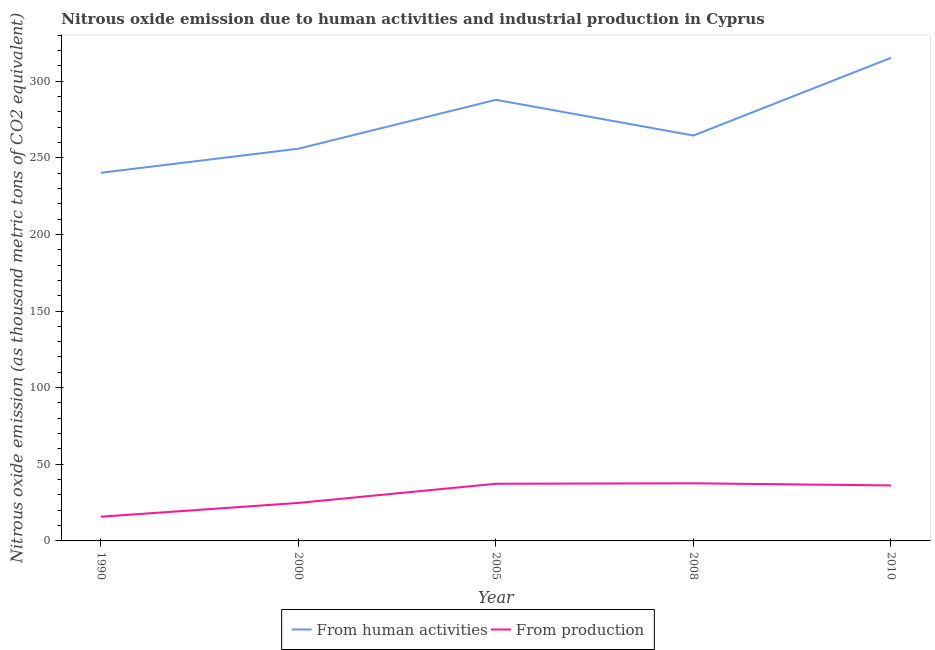Does the line corresponding to amount of emissions generated from industries intersect with the line corresponding to amount of emissions from human activities?
Your response must be concise. No. Is the number of lines equal to the number of legend labels?
Your answer should be compact. Yes. What is the amount of emissions from human activities in 2008?
Make the answer very short. 264.5. Across all years, what is the maximum amount of emissions from human activities?
Offer a very short reply. 315.2. Across all years, what is the minimum amount of emissions from human activities?
Your response must be concise. 240.2. What is the total amount of emissions from human activities in the graph?
Ensure brevity in your answer.  1363.6. What is the difference between the amount of emissions from human activities in 1990 and that in 2005?
Offer a terse response. -47.6. What is the difference between the amount of emissions generated from industries in 2008 and the amount of emissions from human activities in 1990?
Your response must be concise. -202.6. What is the average amount of emissions from human activities per year?
Ensure brevity in your answer.  272.72. In the year 2000, what is the difference between the amount of emissions from human activities and amount of emissions generated from industries?
Provide a succinct answer. 231.1. What is the ratio of the amount of emissions from human activities in 1990 to that in 2000?
Your response must be concise. 0.94. Is the amount of emissions generated from industries in 2000 less than that in 2010?
Your answer should be compact. Yes. What is the difference between the highest and the second highest amount of emissions generated from industries?
Your answer should be compact. 0.3. What is the difference between the highest and the lowest amount of emissions generated from industries?
Your response must be concise. 21.8. In how many years, is the amount of emissions generated from industries greater than the average amount of emissions generated from industries taken over all years?
Ensure brevity in your answer.  3. Is the sum of the amount of emissions generated from industries in 2000 and 2005 greater than the maximum amount of emissions from human activities across all years?
Ensure brevity in your answer.  No. Is the amount of emissions generated from industries strictly less than the amount of emissions from human activities over the years?
Ensure brevity in your answer.  Yes. How many years are there in the graph?
Keep it short and to the point. 5. What is the difference between two consecutive major ticks on the Y-axis?
Provide a succinct answer. 50. Are the values on the major ticks of Y-axis written in scientific E-notation?
Your answer should be compact. No. Does the graph contain any zero values?
Offer a very short reply. No. Does the graph contain grids?
Make the answer very short. No. Where does the legend appear in the graph?
Provide a short and direct response. Bottom center. How are the legend labels stacked?
Your answer should be very brief. Horizontal. What is the title of the graph?
Offer a very short reply. Nitrous oxide emission due to human activities and industrial production in Cyprus. Does "Commercial service exports" appear as one of the legend labels in the graph?
Keep it short and to the point. No. What is the label or title of the X-axis?
Your answer should be very brief. Year. What is the label or title of the Y-axis?
Ensure brevity in your answer.  Nitrous oxide emission (as thousand metric tons of CO2 equivalent). What is the Nitrous oxide emission (as thousand metric tons of CO2 equivalent) in From human activities in 1990?
Make the answer very short. 240.2. What is the Nitrous oxide emission (as thousand metric tons of CO2 equivalent) in From human activities in 2000?
Provide a succinct answer. 255.9. What is the Nitrous oxide emission (as thousand metric tons of CO2 equivalent) of From production in 2000?
Offer a very short reply. 24.8. What is the Nitrous oxide emission (as thousand metric tons of CO2 equivalent) of From human activities in 2005?
Your answer should be compact. 287.8. What is the Nitrous oxide emission (as thousand metric tons of CO2 equivalent) of From production in 2005?
Your response must be concise. 37.3. What is the Nitrous oxide emission (as thousand metric tons of CO2 equivalent) in From human activities in 2008?
Keep it short and to the point. 264.5. What is the Nitrous oxide emission (as thousand metric tons of CO2 equivalent) of From production in 2008?
Offer a very short reply. 37.6. What is the Nitrous oxide emission (as thousand metric tons of CO2 equivalent) of From human activities in 2010?
Offer a very short reply. 315.2. What is the Nitrous oxide emission (as thousand metric tons of CO2 equivalent) in From production in 2010?
Make the answer very short. 36.2. Across all years, what is the maximum Nitrous oxide emission (as thousand metric tons of CO2 equivalent) of From human activities?
Make the answer very short. 315.2. Across all years, what is the maximum Nitrous oxide emission (as thousand metric tons of CO2 equivalent) in From production?
Ensure brevity in your answer.  37.6. Across all years, what is the minimum Nitrous oxide emission (as thousand metric tons of CO2 equivalent) of From human activities?
Your response must be concise. 240.2. What is the total Nitrous oxide emission (as thousand metric tons of CO2 equivalent) of From human activities in the graph?
Offer a very short reply. 1363.6. What is the total Nitrous oxide emission (as thousand metric tons of CO2 equivalent) in From production in the graph?
Your response must be concise. 151.7. What is the difference between the Nitrous oxide emission (as thousand metric tons of CO2 equivalent) in From human activities in 1990 and that in 2000?
Give a very brief answer. -15.7. What is the difference between the Nitrous oxide emission (as thousand metric tons of CO2 equivalent) in From human activities in 1990 and that in 2005?
Your answer should be compact. -47.6. What is the difference between the Nitrous oxide emission (as thousand metric tons of CO2 equivalent) in From production in 1990 and that in 2005?
Offer a terse response. -21.5. What is the difference between the Nitrous oxide emission (as thousand metric tons of CO2 equivalent) in From human activities in 1990 and that in 2008?
Your answer should be very brief. -24.3. What is the difference between the Nitrous oxide emission (as thousand metric tons of CO2 equivalent) of From production in 1990 and that in 2008?
Make the answer very short. -21.8. What is the difference between the Nitrous oxide emission (as thousand metric tons of CO2 equivalent) of From human activities in 1990 and that in 2010?
Offer a very short reply. -75. What is the difference between the Nitrous oxide emission (as thousand metric tons of CO2 equivalent) in From production in 1990 and that in 2010?
Make the answer very short. -20.4. What is the difference between the Nitrous oxide emission (as thousand metric tons of CO2 equivalent) in From human activities in 2000 and that in 2005?
Ensure brevity in your answer.  -31.9. What is the difference between the Nitrous oxide emission (as thousand metric tons of CO2 equivalent) of From production in 2000 and that in 2005?
Your response must be concise. -12.5. What is the difference between the Nitrous oxide emission (as thousand metric tons of CO2 equivalent) of From human activities in 2000 and that in 2008?
Keep it short and to the point. -8.6. What is the difference between the Nitrous oxide emission (as thousand metric tons of CO2 equivalent) in From production in 2000 and that in 2008?
Offer a terse response. -12.8. What is the difference between the Nitrous oxide emission (as thousand metric tons of CO2 equivalent) of From human activities in 2000 and that in 2010?
Offer a terse response. -59.3. What is the difference between the Nitrous oxide emission (as thousand metric tons of CO2 equivalent) of From human activities in 2005 and that in 2008?
Offer a terse response. 23.3. What is the difference between the Nitrous oxide emission (as thousand metric tons of CO2 equivalent) of From production in 2005 and that in 2008?
Ensure brevity in your answer.  -0.3. What is the difference between the Nitrous oxide emission (as thousand metric tons of CO2 equivalent) in From human activities in 2005 and that in 2010?
Your response must be concise. -27.4. What is the difference between the Nitrous oxide emission (as thousand metric tons of CO2 equivalent) of From human activities in 2008 and that in 2010?
Keep it short and to the point. -50.7. What is the difference between the Nitrous oxide emission (as thousand metric tons of CO2 equivalent) of From human activities in 1990 and the Nitrous oxide emission (as thousand metric tons of CO2 equivalent) of From production in 2000?
Your answer should be compact. 215.4. What is the difference between the Nitrous oxide emission (as thousand metric tons of CO2 equivalent) in From human activities in 1990 and the Nitrous oxide emission (as thousand metric tons of CO2 equivalent) in From production in 2005?
Provide a succinct answer. 202.9. What is the difference between the Nitrous oxide emission (as thousand metric tons of CO2 equivalent) of From human activities in 1990 and the Nitrous oxide emission (as thousand metric tons of CO2 equivalent) of From production in 2008?
Your answer should be compact. 202.6. What is the difference between the Nitrous oxide emission (as thousand metric tons of CO2 equivalent) in From human activities in 1990 and the Nitrous oxide emission (as thousand metric tons of CO2 equivalent) in From production in 2010?
Give a very brief answer. 204. What is the difference between the Nitrous oxide emission (as thousand metric tons of CO2 equivalent) of From human activities in 2000 and the Nitrous oxide emission (as thousand metric tons of CO2 equivalent) of From production in 2005?
Provide a succinct answer. 218.6. What is the difference between the Nitrous oxide emission (as thousand metric tons of CO2 equivalent) of From human activities in 2000 and the Nitrous oxide emission (as thousand metric tons of CO2 equivalent) of From production in 2008?
Your answer should be very brief. 218.3. What is the difference between the Nitrous oxide emission (as thousand metric tons of CO2 equivalent) of From human activities in 2000 and the Nitrous oxide emission (as thousand metric tons of CO2 equivalent) of From production in 2010?
Keep it short and to the point. 219.7. What is the difference between the Nitrous oxide emission (as thousand metric tons of CO2 equivalent) in From human activities in 2005 and the Nitrous oxide emission (as thousand metric tons of CO2 equivalent) in From production in 2008?
Keep it short and to the point. 250.2. What is the difference between the Nitrous oxide emission (as thousand metric tons of CO2 equivalent) in From human activities in 2005 and the Nitrous oxide emission (as thousand metric tons of CO2 equivalent) in From production in 2010?
Give a very brief answer. 251.6. What is the difference between the Nitrous oxide emission (as thousand metric tons of CO2 equivalent) of From human activities in 2008 and the Nitrous oxide emission (as thousand metric tons of CO2 equivalent) of From production in 2010?
Offer a terse response. 228.3. What is the average Nitrous oxide emission (as thousand metric tons of CO2 equivalent) in From human activities per year?
Keep it short and to the point. 272.72. What is the average Nitrous oxide emission (as thousand metric tons of CO2 equivalent) in From production per year?
Keep it short and to the point. 30.34. In the year 1990, what is the difference between the Nitrous oxide emission (as thousand metric tons of CO2 equivalent) in From human activities and Nitrous oxide emission (as thousand metric tons of CO2 equivalent) in From production?
Give a very brief answer. 224.4. In the year 2000, what is the difference between the Nitrous oxide emission (as thousand metric tons of CO2 equivalent) of From human activities and Nitrous oxide emission (as thousand metric tons of CO2 equivalent) of From production?
Offer a very short reply. 231.1. In the year 2005, what is the difference between the Nitrous oxide emission (as thousand metric tons of CO2 equivalent) in From human activities and Nitrous oxide emission (as thousand metric tons of CO2 equivalent) in From production?
Offer a very short reply. 250.5. In the year 2008, what is the difference between the Nitrous oxide emission (as thousand metric tons of CO2 equivalent) in From human activities and Nitrous oxide emission (as thousand metric tons of CO2 equivalent) in From production?
Your answer should be very brief. 226.9. In the year 2010, what is the difference between the Nitrous oxide emission (as thousand metric tons of CO2 equivalent) of From human activities and Nitrous oxide emission (as thousand metric tons of CO2 equivalent) of From production?
Your answer should be compact. 279. What is the ratio of the Nitrous oxide emission (as thousand metric tons of CO2 equivalent) of From human activities in 1990 to that in 2000?
Your answer should be very brief. 0.94. What is the ratio of the Nitrous oxide emission (as thousand metric tons of CO2 equivalent) in From production in 1990 to that in 2000?
Offer a terse response. 0.64. What is the ratio of the Nitrous oxide emission (as thousand metric tons of CO2 equivalent) of From human activities in 1990 to that in 2005?
Offer a terse response. 0.83. What is the ratio of the Nitrous oxide emission (as thousand metric tons of CO2 equivalent) of From production in 1990 to that in 2005?
Offer a terse response. 0.42. What is the ratio of the Nitrous oxide emission (as thousand metric tons of CO2 equivalent) of From human activities in 1990 to that in 2008?
Ensure brevity in your answer.  0.91. What is the ratio of the Nitrous oxide emission (as thousand metric tons of CO2 equivalent) in From production in 1990 to that in 2008?
Give a very brief answer. 0.42. What is the ratio of the Nitrous oxide emission (as thousand metric tons of CO2 equivalent) of From human activities in 1990 to that in 2010?
Offer a very short reply. 0.76. What is the ratio of the Nitrous oxide emission (as thousand metric tons of CO2 equivalent) of From production in 1990 to that in 2010?
Provide a short and direct response. 0.44. What is the ratio of the Nitrous oxide emission (as thousand metric tons of CO2 equivalent) in From human activities in 2000 to that in 2005?
Give a very brief answer. 0.89. What is the ratio of the Nitrous oxide emission (as thousand metric tons of CO2 equivalent) in From production in 2000 to that in 2005?
Your answer should be very brief. 0.66. What is the ratio of the Nitrous oxide emission (as thousand metric tons of CO2 equivalent) in From human activities in 2000 to that in 2008?
Provide a succinct answer. 0.97. What is the ratio of the Nitrous oxide emission (as thousand metric tons of CO2 equivalent) in From production in 2000 to that in 2008?
Offer a very short reply. 0.66. What is the ratio of the Nitrous oxide emission (as thousand metric tons of CO2 equivalent) in From human activities in 2000 to that in 2010?
Make the answer very short. 0.81. What is the ratio of the Nitrous oxide emission (as thousand metric tons of CO2 equivalent) in From production in 2000 to that in 2010?
Give a very brief answer. 0.69. What is the ratio of the Nitrous oxide emission (as thousand metric tons of CO2 equivalent) in From human activities in 2005 to that in 2008?
Give a very brief answer. 1.09. What is the ratio of the Nitrous oxide emission (as thousand metric tons of CO2 equivalent) in From production in 2005 to that in 2008?
Ensure brevity in your answer.  0.99. What is the ratio of the Nitrous oxide emission (as thousand metric tons of CO2 equivalent) in From human activities in 2005 to that in 2010?
Make the answer very short. 0.91. What is the ratio of the Nitrous oxide emission (as thousand metric tons of CO2 equivalent) of From production in 2005 to that in 2010?
Provide a succinct answer. 1.03. What is the ratio of the Nitrous oxide emission (as thousand metric tons of CO2 equivalent) in From human activities in 2008 to that in 2010?
Your answer should be very brief. 0.84. What is the ratio of the Nitrous oxide emission (as thousand metric tons of CO2 equivalent) of From production in 2008 to that in 2010?
Offer a very short reply. 1.04. What is the difference between the highest and the second highest Nitrous oxide emission (as thousand metric tons of CO2 equivalent) in From human activities?
Provide a short and direct response. 27.4. What is the difference between the highest and the lowest Nitrous oxide emission (as thousand metric tons of CO2 equivalent) in From production?
Offer a very short reply. 21.8. 